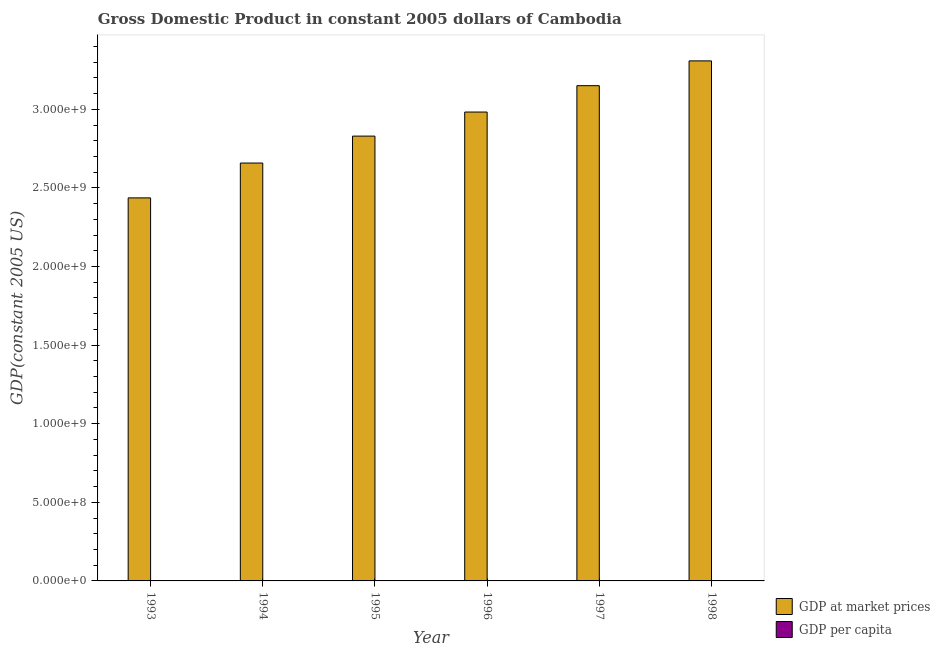How many different coloured bars are there?
Offer a very short reply. 2. Are the number of bars per tick equal to the number of legend labels?
Provide a succinct answer. Yes. How many bars are there on the 4th tick from the left?
Ensure brevity in your answer.  2. What is the gdp at market prices in 1998?
Ensure brevity in your answer.  3.31e+09. Across all years, what is the maximum gdp per capita?
Ensure brevity in your answer.  284.16. Across all years, what is the minimum gdp per capita?
Offer a very short reply. 243.48. In which year was the gdp at market prices maximum?
Your answer should be compact. 1998. In which year was the gdp at market prices minimum?
Give a very brief answer. 1993. What is the total gdp at market prices in the graph?
Provide a short and direct response. 1.74e+1. What is the difference between the gdp at market prices in 1994 and that in 1998?
Provide a succinct answer. -6.50e+08. What is the difference between the gdp at market prices in 1997 and the gdp per capita in 1998?
Provide a succinct answer. -1.58e+08. What is the average gdp per capita per year?
Provide a succinct answer. 266.23. In the year 1995, what is the difference between the gdp at market prices and gdp per capita?
Ensure brevity in your answer.  0. In how many years, is the gdp at market prices greater than 2800000000 US$?
Your response must be concise. 4. What is the ratio of the gdp at market prices in 1993 to that in 1996?
Your response must be concise. 0.82. Is the gdp per capita in 1993 less than that in 1994?
Provide a short and direct response. Yes. Is the difference between the gdp at market prices in 1995 and 1997 greater than the difference between the gdp per capita in 1995 and 1997?
Give a very brief answer. No. What is the difference between the highest and the second highest gdp per capita?
Keep it short and to the point. 6.33. What is the difference between the highest and the lowest gdp at market prices?
Offer a very short reply. 8.72e+08. What does the 1st bar from the left in 1997 represents?
Your answer should be very brief. GDP at market prices. What does the 2nd bar from the right in 1998 represents?
Give a very brief answer. GDP at market prices. How many bars are there?
Your answer should be very brief. 12. Are all the bars in the graph horizontal?
Keep it short and to the point. No. What is the difference between two consecutive major ticks on the Y-axis?
Your answer should be very brief. 5.00e+08. Where does the legend appear in the graph?
Your answer should be compact. Bottom right. What is the title of the graph?
Your answer should be compact. Gross Domestic Product in constant 2005 dollars of Cambodia. What is the label or title of the X-axis?
Ensure brevity in your answer.  Year. What is the label or title of the Y-axis?
Keep it short and to the point. GDP(constant 2005 US). What is the GDP(constant 2005 US) in GDP at market prices in 1993?
Provide a short and direct response. 2.44e+09. What is the GDP(constant 2005 US) of GDP per capita in 1993?
Give a very brief answer. 243.48. What is the GDP(constant 2005 US) in GDP at market prices in 1994?
Offer a very short reply. 2.66e+09. What is the GDP(constant 2005 US) of GDP per capita in 1994?
Your answer should be very brief. 256.71. What is the GDP(constant 2005 US) in GDP at market prices in 1995?
Ensure brevity in your answer.  2.83e+09. What is the GDP(constant 2005 US) of GDP per capita in 1995?
Your answer should be very brief. 264.58. What is the GDP(constant 2005 US) in GDP at market prices in 1996?
Provide a short and direct response. 2.98e+09. What is the GDP(constant 2005 US) of GDP per capita in 1996?
Your answer should be very brief. 270.61. What is the GDP(constant 2005 US) of GDP at market prices in 1997?
Provide a succinct answer. 3.15e+09. What is the GDP(constant 2005 US) of GDP per capita in 1997?
Offer a very short reply. 277.83. What is the GDP(constant 2005 US) in GDP at market prices in 1998?
Provide a succinct answer. 3.31e+09. What is the GDP(constant 2005 US) in GDP per capita in 1998?
Give a very brief answer. 284.16. Across all years, what is the maximum GDP(constant 2005 US) of GDP at market prices?
Your answer should be compact. 3.31e+09. Across all years, what is the maximum GDP(constant 2005 US) of GDP per capita?
Make the answer very short. 284.16. Across all years, what is the minimum GDP(constant 2005 US) in GDP at market prices?
Provide a succinct answer. 2.44e+09. Across all years, what is the minimum GDP(constant 2005 US) in GDP per capita?
Your response must be concise. 243.48. What is the total GDP(constant 2005 US) in GDP at market prices in the graph?
Ensure brevity in your answer.  1.74e+1. What is the total GDP(constant 2005 US) in GDP per capita in the graph?
Give a very brief answer. 1597.37. What is the difference between the GDP(constant 2005 US) of GDP at market prices in 1993 and that in 1994?
Your answer should be very brief. -2.22e+08. What is the difference between the GDP(constant 2005 US) in GDP per capita in 1993 and that in 1994?
Offer a very short reply. -13.22. What is the difference between the GDP(constant 2005 US) in GDP at market prices in 1993 and that in 1995?
Provide a succinct answer. -3.93e+08. What is the difference between the GDP(constant 2005 US) of GDP per capita in 1993 and that in 1995?
Provide a succinct answer. -21.1. What is the difference between the GDP(constant 2005 US) in GDP at market prices in 1993 and that in 1996?
Offer a very short reply. -5.46e+08. What is the difference between the GDP(constant 2005 US) in GDP per capita in 1993 and that in 1996?
Make the answer very short. -27.12. What is the difference between the GDP(constant 2005 US) in GDP at market prices in 1993 and that in 1997?
Provide a short and direct response. -7.14e+08. What is the difference between the GDP(constant 2005 US) of GDP per capita in 1993 and that in 1997?
Your response must be concise. -34.35. What is the difference between the GDP(constant 2005 US) of GDP at market prices in 1993 and that in 1998?
Keep it short and to the point. -8.72e+08. What is the difference between the GDP(constant 2005 US) in GDP per capita in 1993 and that in 1998?
Ensure brevity in your answer.  -40.68. What is the difference between the GDP(constant 2005 US) of GDP at market prices in 1994 and that in 1995?
Provide a succinct answer. -1.71e+08. What is the difference between the GDP(constant 2005 US) in GDP per capita in 1994 and that in 1995?
Provide a short and direct response. -7.87. What is the difference between the GDP(constant 2005 US) of GDP at market prices in 1994 and that in 1996?
Offer a terse response. -3.24e+08. What is the difference between the GDP(constant 2005 US) in GDP per capita in 1994 and that in 1996?
Give a very brief answer. -13.9. What is the difference between the GDP(constant 2005 US) of GDP at market prices in 1994 and that in 1997?
Your answer should be very brief. -4.92e+08. What is the difference between the GDP(constant 2005 US) of GDP per capita in 1994 and that in 1997?
Keep it short and to the point. -21.13. What is the difference between the GDP(constant 2005 US) in GDP at market prices in 1994 and that in 1998?
Keep it short and to the point. -6.50e+08. What is the difference between the GDP(constant 2005 US) in GDP per capita in 1994 and that in 1998?
Provide a short and direct response. -27.46. What is the difference between the GDP(constant 2005 US) in GDP at market prices in 1995 and that in 1996?
Offer a very short reply. -1.53e+08. What is the difference between the GDP(constant 2005 US) in GDP per capita in 1995 and that in 1996?
Give a very brief answer. -6.03. What is the difference between the GDP(constant 2005 US) in GDP at market prices in 1995 and that in 1997?
Provide a succinct answer. -3.21e+08. What is the difference between the GDP(constant 2005 US) of GDP per capita in 1995 and that in 1997?
Ensure brevity in your answer.  -13.26. What is the difference between the GDP(constant 2005 US) in GDP at market prices in 1995 and that in 1998?
Offer a terse response. -4.79e+08. What is the difference between the GDP(constant 2005 US) in GDP per capita in 1995 and that in 1998?
Provide a short and direct response. -19.58. What is the difference between the GDP(constant 2005 US) of GDP at market prices in 1996 and that in 1997?
Offer a terse response. -1.68e+08. What is the difference between the GDP(constant 2005 US) in GDP per capita in 1996 and that in 1997?
Make the answer very short. -7.23. What is the difference between the GDP(constant 2005 US) in GDP at market prices in 1996 and that in 1998?
Your answer should be very brief. -3.25e+08. What is the difference between the GDP(constant 2005 US) in GDP per capita in 1996 and that in 1998?
Offer a terse response. -13.56. What is the difference between the GDP(constant 2005 US) in GDP at market prices in 1997 and that in 1998?
Provide a succinct answer. -1.58e+08. What is the difference between the GDP(constant 2005 US) in GDP per capita in 1997 and that in 1998?
Your response must be concise. -6.33. What is the difference between the GDP(constant 2005 US) in GDP at market prices in 1993 and the GDP(constant 2005 US) in GDP per capita in 1994?
Your response must be concise. 2.44e+09. What is the difference between the GDP(constant 2005 US) of GDP at market prices in 1993 and the GDP(constant 2005 US) of GDP per capita in 1995?
Keep it short and to the point. 2.44e+09. What is the difference between the GDP(constant 2005 US) of GDP at market prices in 1993 and the GDP(constant 2005 US) of GDP per capita in 1996?
Provide a short and direct response. 2.44e+09. What is the difference between the GDP(constant 2005 US) of GDP at market prices in 1993 and the GDP(constant 2005 US) of GDP per capita in 1997?
Offer a terse response. 2.44e+09. What is the difference between the GDP(constant 2005 US) in GDP at market prices in 1993 and the GDP(constant 2005 US) in GDP per capita in 1998?
Offer a terse response. 2.44e+09. What is the difference between the GDP(constant 2005 US) of GDP at market prices in 1994 and the GDP(constant 2005 US) of GDP per capita in 1995?
Your answer should be very brief. 2.66e+09. What is the difference between the GDP(constant 2005 US) of GDP at market prices in 1994 and the GDP(constant 2005 US) of GDP per capita in 1996?
Make the answer very short. 2.66e+09. What is the difference between the GDP(constant 2005 US) of GDP at market prices in 1994 and the GDP(constant 2005 US) of GDP per capita in 1997?
Offer a very short reply. 2.66e+09. What is the difference between the GDP(constant 2005 US) in GDP at market prices in 1994 and the GDP(constant 2005 US) in GDP per capita in 1998?
Offer a terse response. 2.66e+09. What is the difference between the GDP(constant 2005 US) in GDP at market prices in 1995 and the GDP(constant 2005 US) in GDP per capita in 1996?
Offer a very short reply. 2.83e+09. What is the difference between the GDP(constant 2005 US) in GDP at market prices in 1995 and the GDP(constant 2005 US) in GDP per capita in 1997?
Provide a succinct answer. 2.83e+09. What is the difference between the GDP(constant 2005 US) of GDP at market prices in 1995 and the GDP(constant 2005 US) of GDP per capita in 1998?
Your answer should be compact. 2.83e+09. What is the difference between the GDP(constant 2005 US) in GDP at market prices in 1996 and the GDP(constant 2005 US) in GDP per capita in 1997?
Offer a very short reply. 2.98e+09. What is the difference between the GDP(constant 2005 US) in GDP at market prices in 1996 and the GDP(constant 2005 US) in GDP per capita in 1998?
Provide a short and direct response. 2.98e+09. What is the difference between the GDP(constant 2005 US) in GDP at market prices in 1997 and the GDP(constant 2005 US) in GDP per capita in 1998?
Offer a very short reply. 3.15e+09. What is the average GDP(constant 2005 US) in GDP at market prices per year?
Provide a short and direct response. 2.89e+09. What is the average GDP(constant 2005 US) in GDP per capita per year?
Your response must be concise. 266.23. In the year 1993, what is the difference between the GDP(constant 2005 US) of GDP at market prices and GDP(constant 2005 US) of GDP per capita?
Your answer should be compact. 2.44e+09. In the year 1994, what is the difference between the GDP(constant 2005 US) in GDP at market prices and GDP(constant 2005 US) in GDP per capita?
Offer a very short reply. 2.66e+09. In the year 1995, what is the difference between the GDP(constant 2005 US) in GDP at market prices and GDP(constant 2005 US) in GDP per capita?
Your response must be concise. 2.83e+09. In the year 1996, what is the difference between the GDP(constant 2005 US) of GDP at market prices and GDP(constant 2005 US) of GDP per capita?
Ensure brevity in your answer.  2.98e+09. In the year 1997, what is the difference between the GDP(constant 2005 US) of GDP at market prices and GDP(constant 2005 US) of GDP per capita?
Give a very brief answer. 3.15e+09. In the year 1998, what is the difference between the GDP(constant 2005 US) in GDP at market prices and GDP(constant 2005 US) in GDP per capita?
Your answer should be very brief. 3.31e+09. What is the ratio of the GDP(constant 2005 US) in GDP at market prices in 1993 to that in 1994?
Keep it short and to the point. 0.92. What is the ratio of the GDP(constant 2005 US) of GDP per capita in 1993 to that in 1994?
Keep it short and to the point. 0.95. What is the ratio of the GDP(constant 2005 US) of GDP at market prices in 1993 to that in 1995?
Make the answer very short. 0.86. What is the ratio of the GDP(constant 2005 US) of GDP per capita in 1993 to that in 1995?
Give a very brief answer. 0.92. What is the ratio of the GDP(constant 2005 US) of GDP at market prices in 1993 to that in 1996?
Offer a very short reply. 0.82. What is the ratio of the GDP(constant 2005 US) in GDP per capita in 1993 to that in 1996?
Provide a short and direct response. 0.9. What is the ratio of the GDP(constant 2005 US) in GDP at market prices in 1993 to that in 1997?
Your response must be concise. 0.77. What is the ratio of the GDP(constant 2005 US) of GDP per capita in 1993 to that in 1997?
Your response must be concise. 0.88. What is the ratio of the GDP(constant 2005 US) of GDP at market prices in 1993 to that in 1998?
Your answer should be very brief. 0.74. What is the ratio of the GDP(constant 2005 US) of GDP per capita in 1993 to that in 1998?
Your answer should be compact. 0.86. What is the ratio of the GDP(constant 2005 US) in GDP at market prices in 1994 to that in 1995?
Your answer should be very brief. 0.94. What is the ratio of the GDP(constant 2005 US) of GDP per capita in 1994 to that in 1995?
Make the answer very short. 0.97. What is the ratio of the GDP(constant 2005 US) in GDP at market prices in 1994 to that in 1996?
Your answer should be compact. 0.89. What is the ratio of the GDP(constant 2005 US) in GDP per capita in 1994 to that in 1996?
Your answer should be very brief. 0.95. What is the ratio of the GDP(constant 2005 US) of GDP at market prices in 1994 to that in 1997?
Provide a short and direct response. 0.84. What is the ratio of the GDP(constant 2005 US) in GDP per capita in 1994 to that in 1997?
Provide a succinct answer. 0.92. What is the ratio of the GDP(constant 2005 US) of GDP at market prices in 1994 to that in 1998?
Keep it short and to the point. 0.8. What is the ratio of the GDP(constant 2005 US) in GDP per capita in 1994 to that in 1998?
Your response must be concise. 0.9. What is the ratio of the GDP(constant 2005 US) of GDP at market prices in 1995 to that in 1996?
Your answer should be very brief. 0.95. What is the ratio of the GDP(constant 2005 US) of GDP per capita in 1995 to that in 1996?
Keep it short and to the point. 0.98. What is the ratio of the GDP(constant 2005 US) in GDP at market prices in 1995 to that in 1997?
Ensure brevity in your answer.  0.9. What is the ratio of the GDP(constant 2005 US) in GDP per capita in 1995 to that in 1997?
Your answer should be compact. 0.95. What is the ratio of the GDP(constant 2005 US) of GDP at market prices in 1995 to that in 1998?
Offer a very short reply. 0.86. What is the ratio of the GDP(constant 2005 US) in GDP per capita in 1995 to that in 1998?
Your response must be concise. 0.93. What is the ratio of the GDP(constant 2005 US) in GDP at market prices in 1996 to that in 1997?
Keep it short and to the point. 0.95. What is the ratio of the GDP(constant 2005 US) of GDP at market prices in 1996 to that in 1998?
Make the answer very short. 0.9. What is the ratio of the GDP(constant 2005 US) of GDP per capita in 1996 to that in 1998?
Keep it short and to the point. 0.95. What is the ratio of the GDP(constant 2005 US) in GDP at market prices in 1997 to that in 1998?
Make the answer very short. 0.95. What is the ratio of the GDP(constant 2005 US) of GDP per capita in 1997 to that in 1998?
Your answer should be compact. 0.98. What is the difference between the highest and the second highest GDP(constant 2005 US) of GDP at market prices?
Your response must be concise. 1.58e+08. What is the difference between the highest and the second highest GDP(constant 2005 US) in GDP per capita?
Keep it short and to the point. 6.33. What is the difference between the highest and the lowest GDP(constant 2005 US) of GDP at market prices?
Offer a terse response. 8.72e+08. What is the difference between the highest and the lowest GDP(constant 2005 US) in GDP per capita?
Make the answer very short. 40.68. 